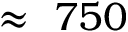<formula> <loc_0><loc_0><loc_500><loc_500>\approx 7 5 0</formula> 